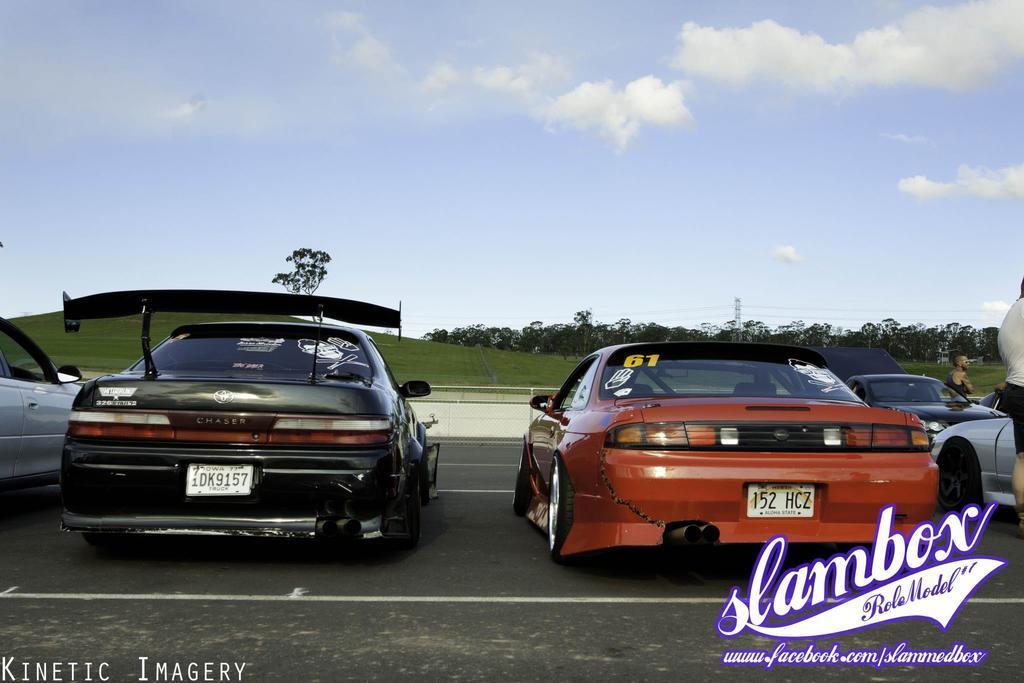Please provide a concise description of this image. This is an outside view. At the bottom there is a road and I can see few cars on the road. On the left side there is a hill. In the background there are some trees. On the right side there are two persons. At the top of the image I can see the sky and clouds. At the bottom of this image I can see some edited text. 